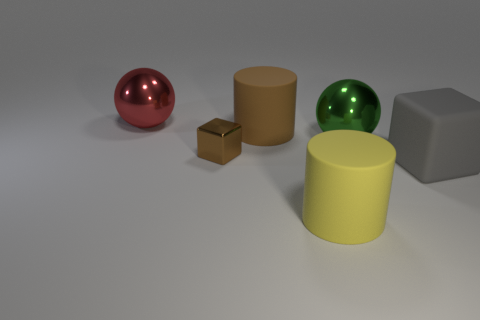What is the brown cylinder made of? While the brown cylinder in the image appears to have a matte surface, determining the exact material from a visual inspection alone can be challenging. However, based on common usage and appearance, it could be made of a material such as cardboard, which is often used for simple, non-reflective cylinders like this one. 